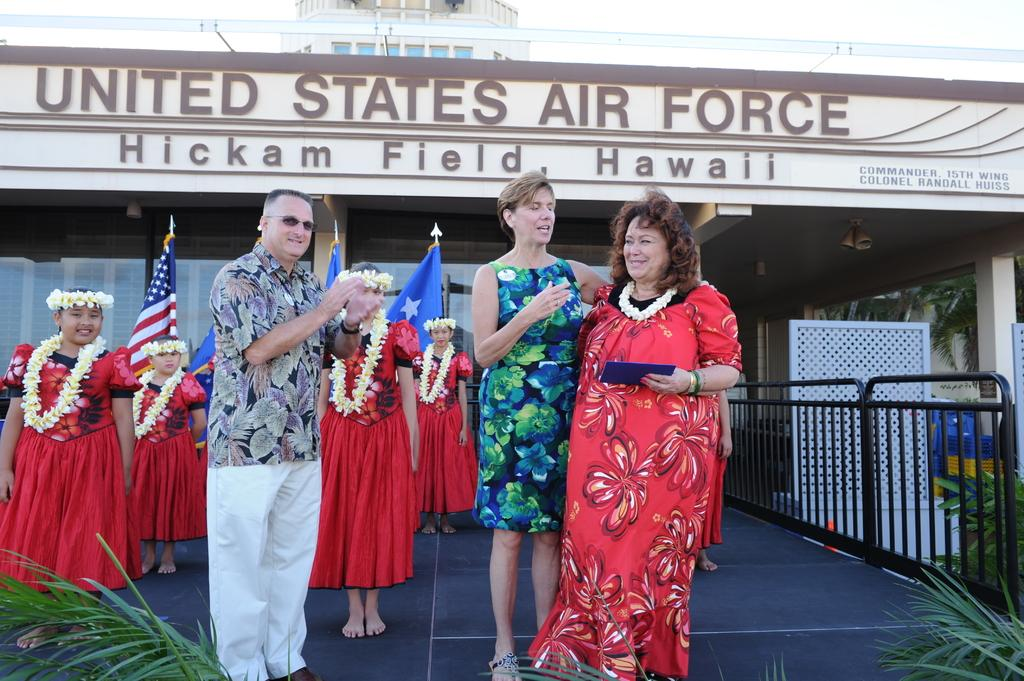What can be observed about the people in the image? There are people wearing different color dresses in the image. What can be seen in the background of the image? There is a building, a railing, a planter, and flags in the background of the image. Are there any other objects visible in the background? Yes, there are other objects in the background of the image. How many plates are being used by the people in the image? There is no mention of plates in the image, so it cannot be determined how many are being used. 